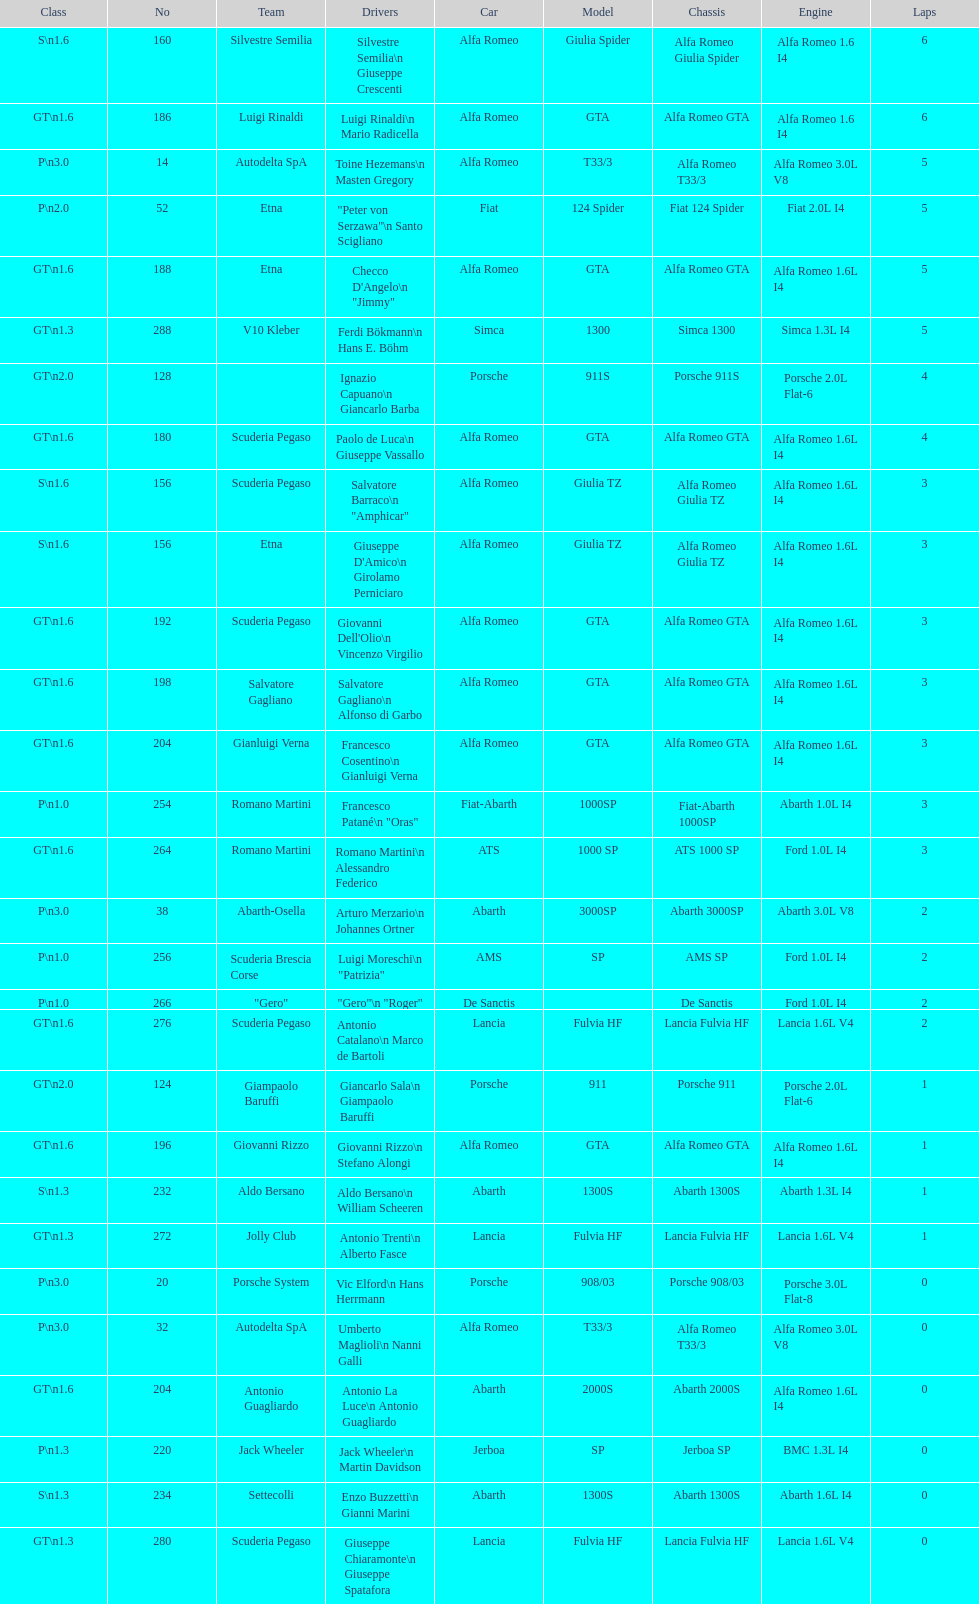His nickname is "jimmy," but what is his full name? Checco D'Angelo. 